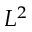Convert formula to latex. <formula><loc_0><loc_0><loc_500><loc_500>L ^ { 2 }</formula> 